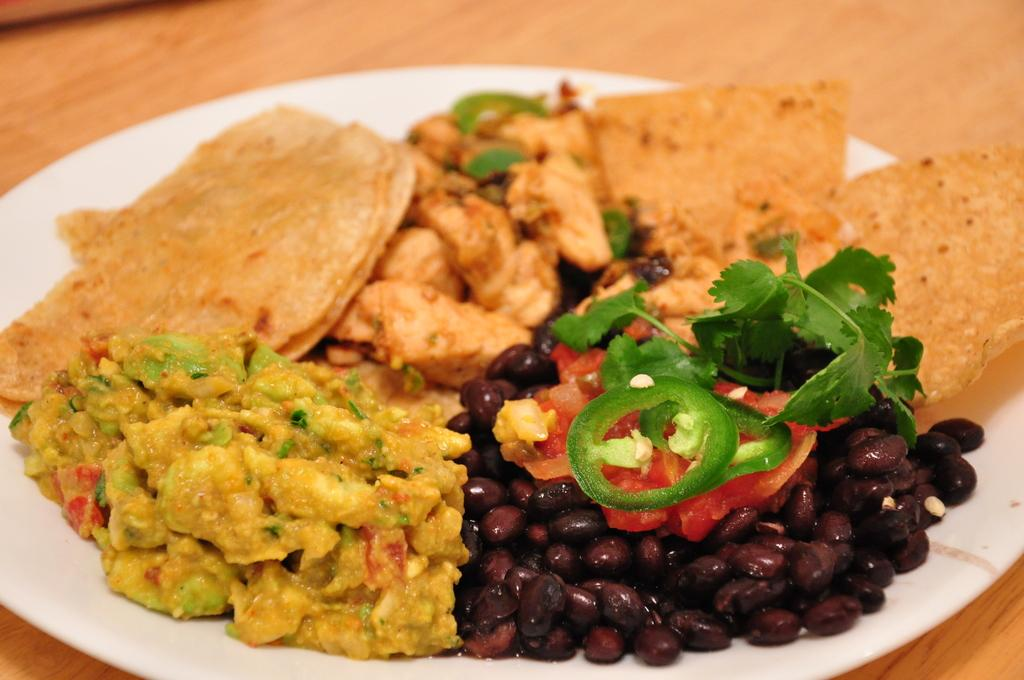What is present on the plate in the image? There are food items in a plate. On what surface is the plate placed? The plate is placed on a wooden surface. What type of calculator is visible on the wooden surface in the image? There is no calculator present in the image; it only features a plate with food items and a wooden surface. 